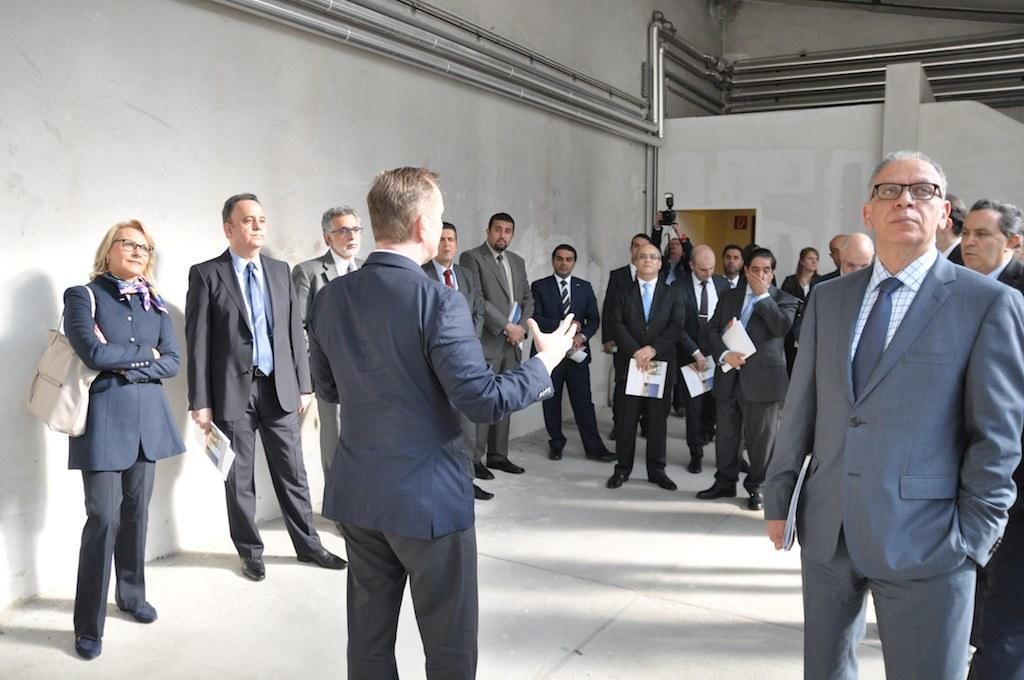Please provide a concise description of this image. This picture describes about group of people, few people wore spectacles and few people holding papers, in the background we can see few pipes on the wall. 